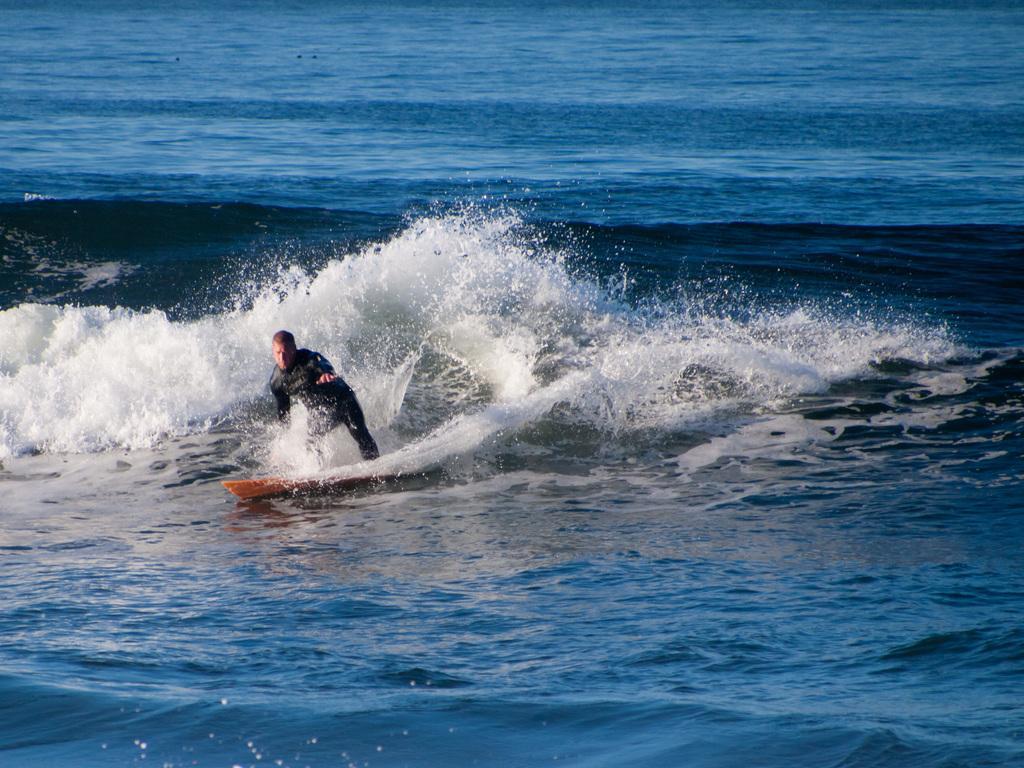Please provide a concise description of this image. In this picture I can observe a man surfing on the surfing board. In the background there is an ocean. 